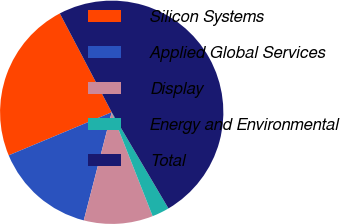Convert chart. <chart><loc_0><loc_0><loc_500><loc_500><pie_chart><fcel>Silicon Systems<fcel>Applied Global Services<fcel>Display<fcel>Energy and Environmental<fcel>Total<nl><fcel>23.61%<fcel>14.67%<fcel>10.0%<fcel>2.51%<fcel>49.2%<nl></chart> 